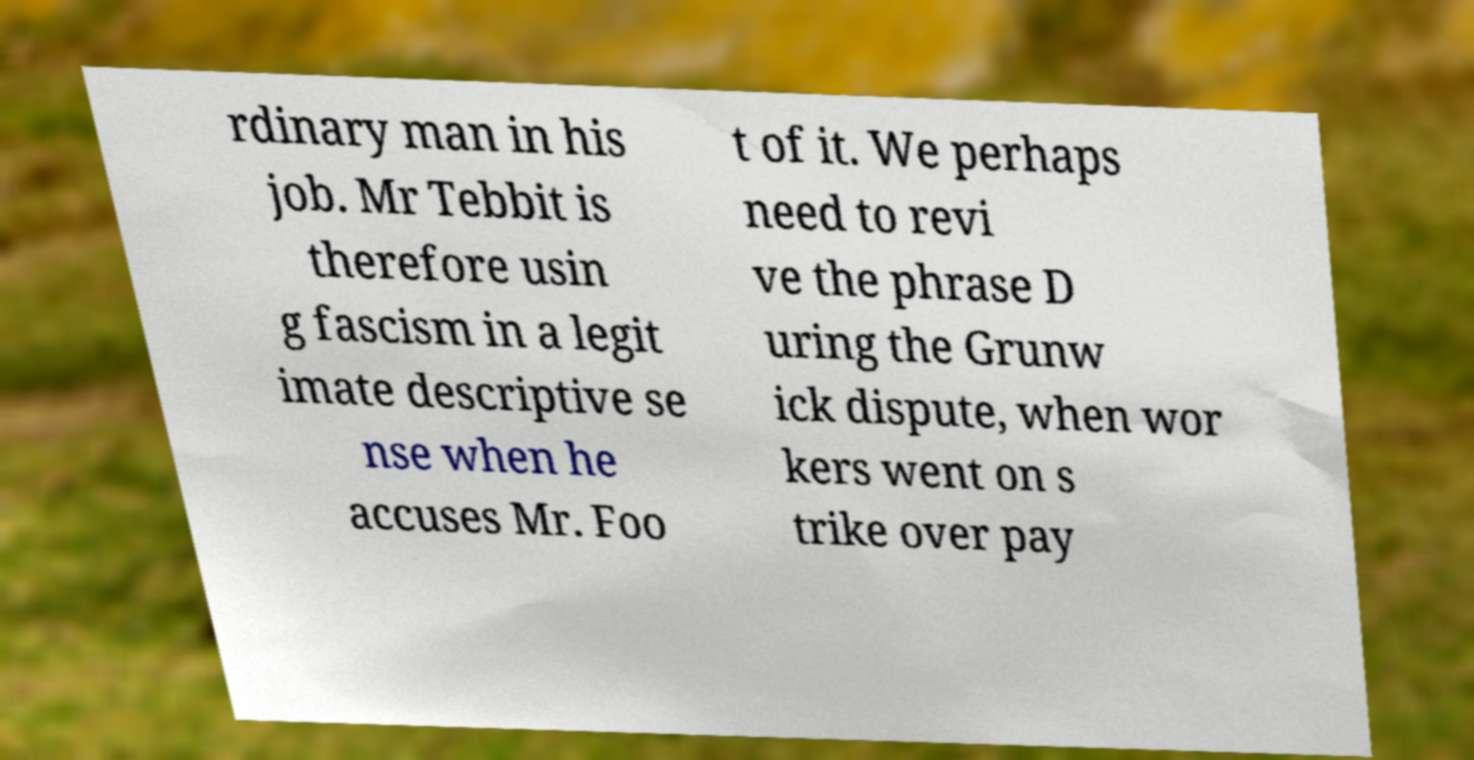For documentation purposes, I need the text within this image transcribed. Could you provide that? rdinary man in his job. Mr Tebbit is therefore usin g fascism in a legit imate descriptive se nse when he accuses Mr. Foo t of it. We perhaps need to revi ve the phrase D uring the Grunw ick dispute, when wor kers went on s trike over pay 